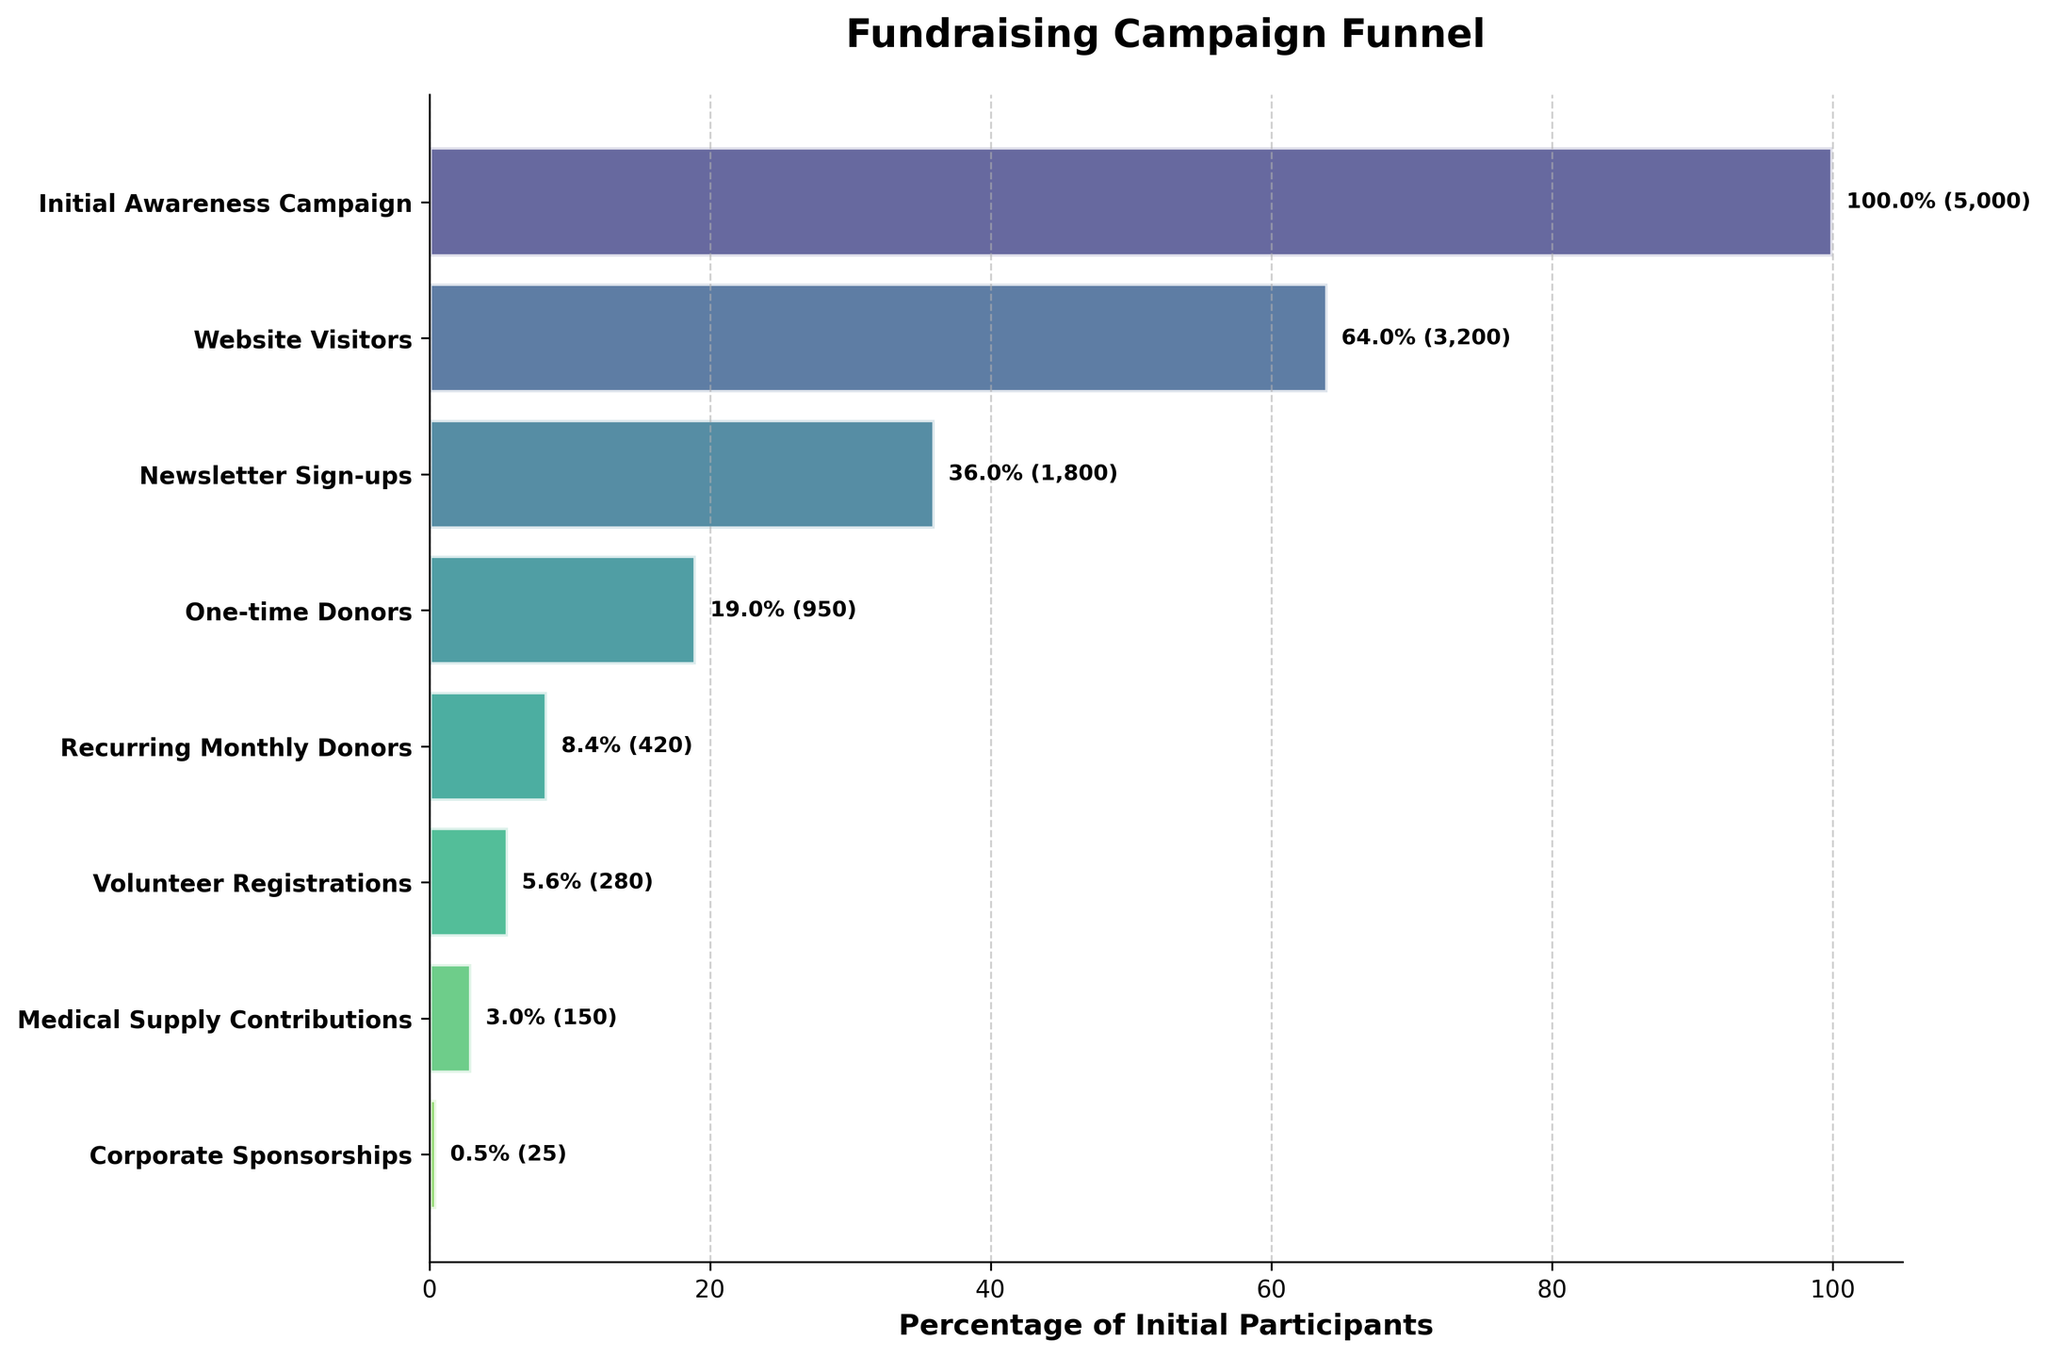What is the title of the funnel chart? The title of the chart is displayed at the top and states the overall subject or purpose of the chart.
Answer: Fundraising Campaign Funnel How many stages are there in the funnel chart? By counting the number of unique labels on the vertical axis, we determine there are eight stages.
Answer: 8 Which stage has the highest number of participants? The first stage in the funnel contains the highest absolute numbers, which can be verified by its position (top of the chart) and the value displayed.
Answer: Initial Awareness Campaign What percentage of participants signed up for the newsletter compared to the initial awareness campaign? To determine this percentage, identify the percentage value next to "Newsletter Sign-ups." The chart shows this directly.
Answer: 36% What is the difference in the number of participants between one-time donors and recurring monthly donors? Subtract the number of participants in the "Recurring Monthly Donors" stage from the "One-time Donors" stage (950 - 420).
Answer: 530 Which stage represents the smallest percentage of the initial participants? Look at the horizontal bars and their corresponding percentages in the figure; the smallest percentage corresponds to the "Corporate Sponsorships" stage.
Answer: Corporate Sponsorships By how much does the number of participants in the Medical Supply Contributions stage exceed that of Volunteer Registrations? View the participant numbers for the "Medical Supply Contributions" and "Volunteer Registrations" stages and subtract the latter from the former (150 - 280, noting a negative difference).
Answer: -130 What is the average number of participants from the stages beginning with Newsletter Sign-ups to Corporate Sponsorships? Sum the participants in the stages (from Newsletter Sign-ups to Corporate Sponsorships) and divide by the number of these stages ((1800 + 950 + 420 + 280 + 150 + 25) / 6).
Answer: 604.2 From initial awareness to corporate sponsorships, how many stages see a greater than 50% drop-off in participants compared to the previous stage? Identify stages where the drop-off in participants is over half, compare each stage's numbers to its predecessor and see that four stages meet this criterion.
Answer: 4 stages 